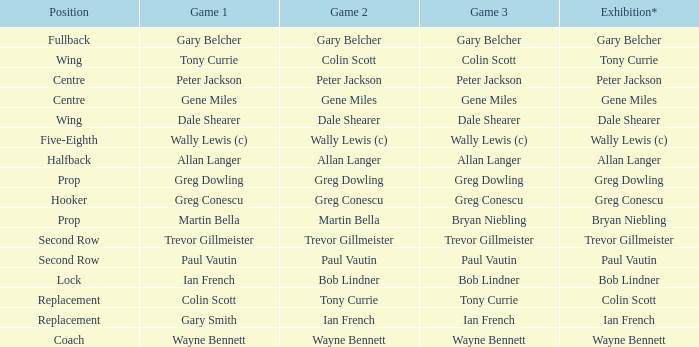What game 3 includes ian french as a game of 2? Ian French. 